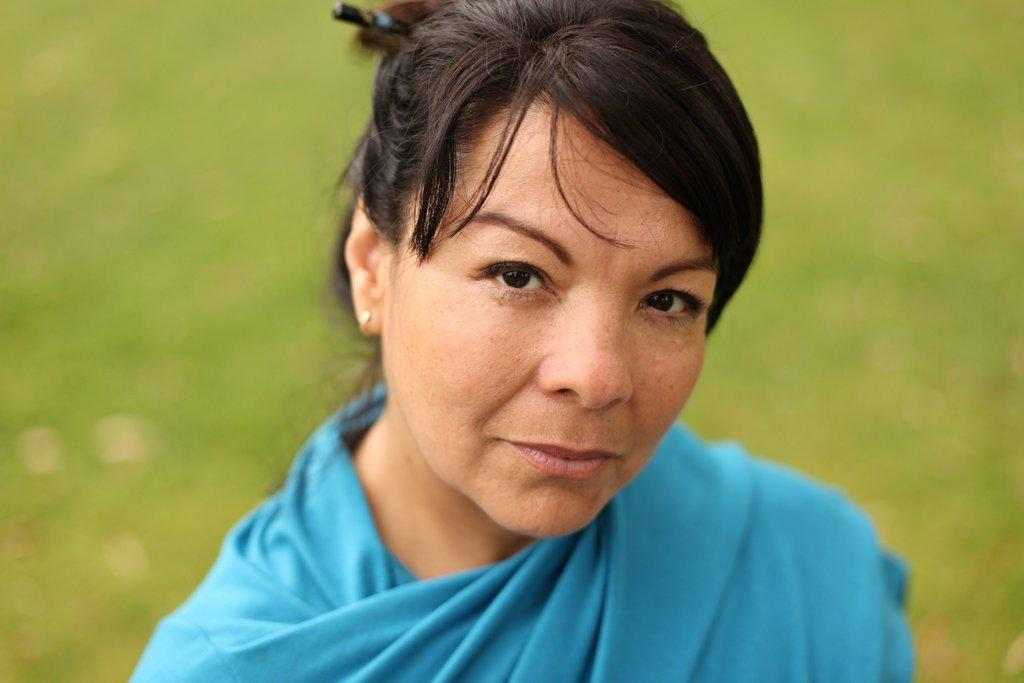What is the main subject of the image? There is a person in the image. What is the person wearing? The person is wearing a blue dress. Can you describe the background of the image? The background of the image is blurred. How many people are in the crowd in the image? There is no crowd present in the image; it features a single person wearing a blue dress. What type of drop can be seen falling from the person's tongue in the image? There is no tongue or drop visible in the image. 